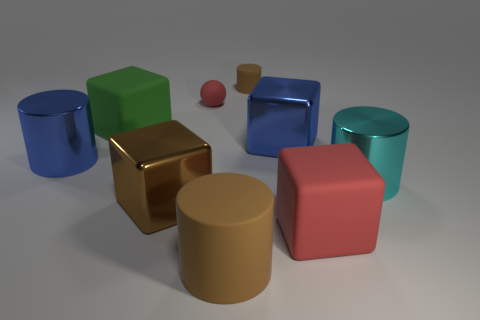What material do the objects in this image seem to be made of? The objects in the image appear to be rendered with different types of materials. The cylinder and the block with reflective surfaces suggest a metallic material, possibly steel or aluminum, due to their high gloss and reflective qualities. The matte-surfaced cube on the left, in contrast, seems to be made of a more diffusive material, likely a type of plastic or rubber, as it does not reflect light in the same way.  Does the image follow any specific pattern or arrangement? The image showcases a random yet balanced arrangement of geometric shapes rendered with a variety of colors and materials. There's no apparent pattern in terms of color or size progression, but the layout provides a sense of visual balance with the objects dispersed across the visual field, creating a harmonious composition with both symmetrical and asymmetrical elements. 